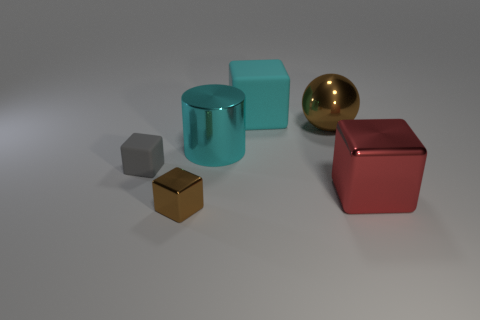Add 4 big metallic cylinders. How many objects exist? 10 Subtract all blocks. How many objects are left? 2 Add 6 red things. How many red things exist? 7 Subtract 1 gray cubes. How many objects are left? 5 Subtract all large red shiny things. Subtract all small gray things. How many objects are left? 4 Add 5 large matte blocks. How many large matte blocks are left? 6 